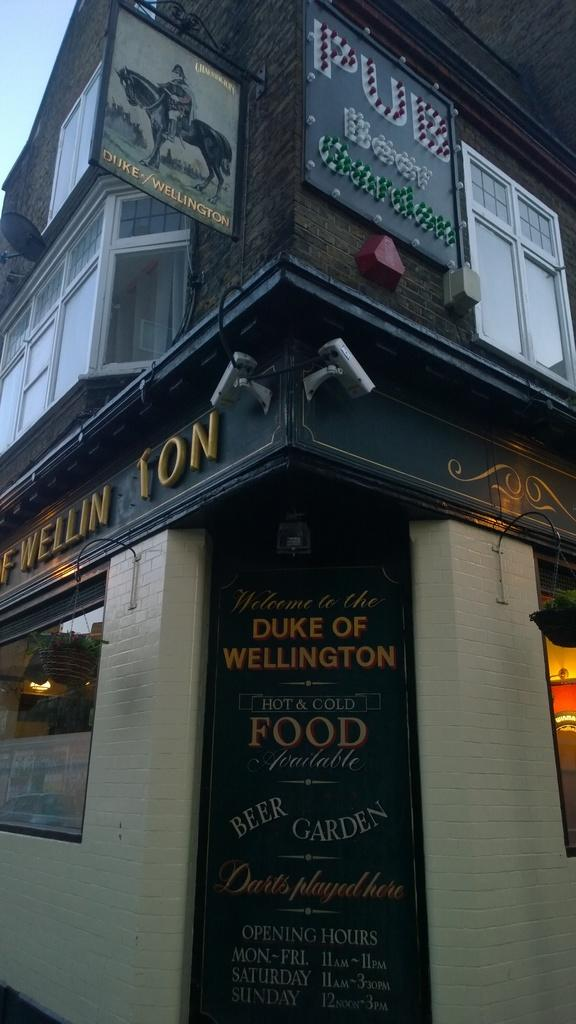What is the main structure in the picture? There is a building in the picture. What can be seen on the building? There are boards on the building with writing on them. What can be seen illuminated in the picture? There are lights visible in the picture. What architectural feature is present on the top of the building? There are windows on the top of the building. How many bikes are parked in front of the building in the image? There are no bikes visible in the image; only the building, boards with writing, lights, and windows are present. 